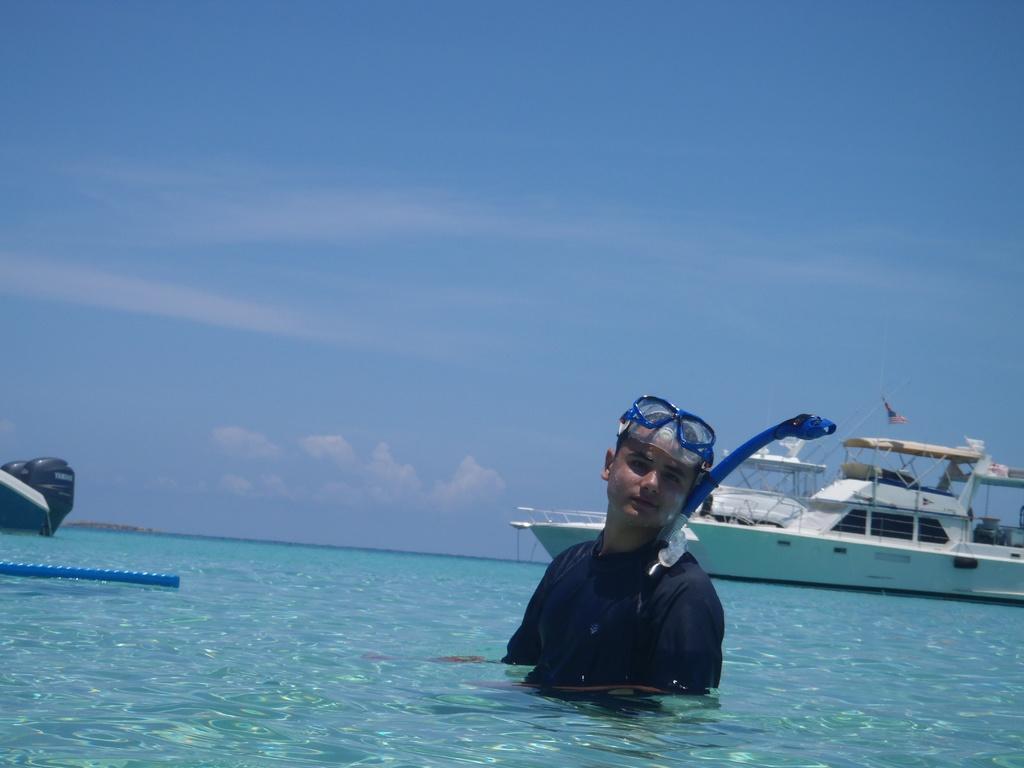In one or two sentences, can you explain what this image depicts? This image consists of a man swimming. At the bottom, there is water. In the background, there is a boat. At the top, there is a sky. 